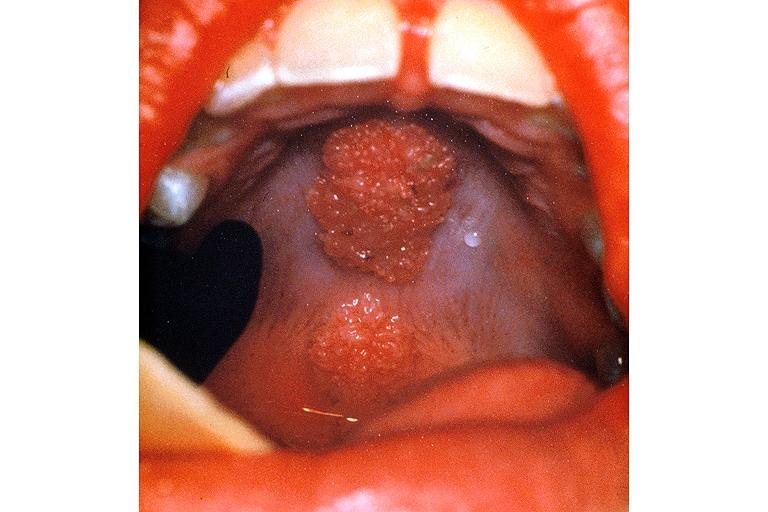what is present?
Answer the question using a single word or phrase. Oral 